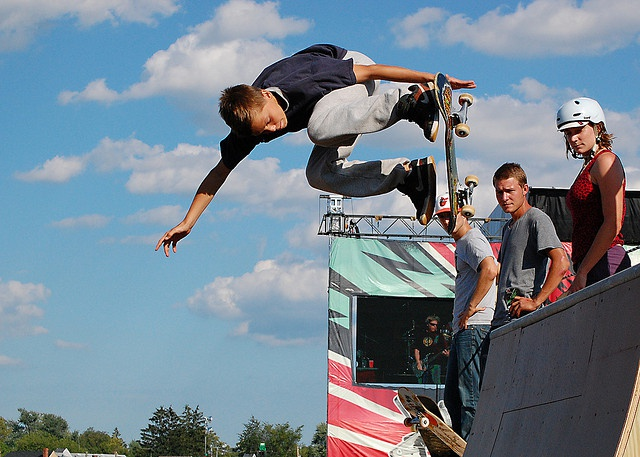Describe the objects in this image and their specific colors. I can see people in darkgray, black, and lightgray tones, people in darkgray, black, maroon, lightgray, and salmon tones, people in darkgray, black, gray, lightgray, and blue tones, people in darkgray, black, gray, and maroon tones, and skateboard in darkgray, black, gray, and lightgray tones in this image. 